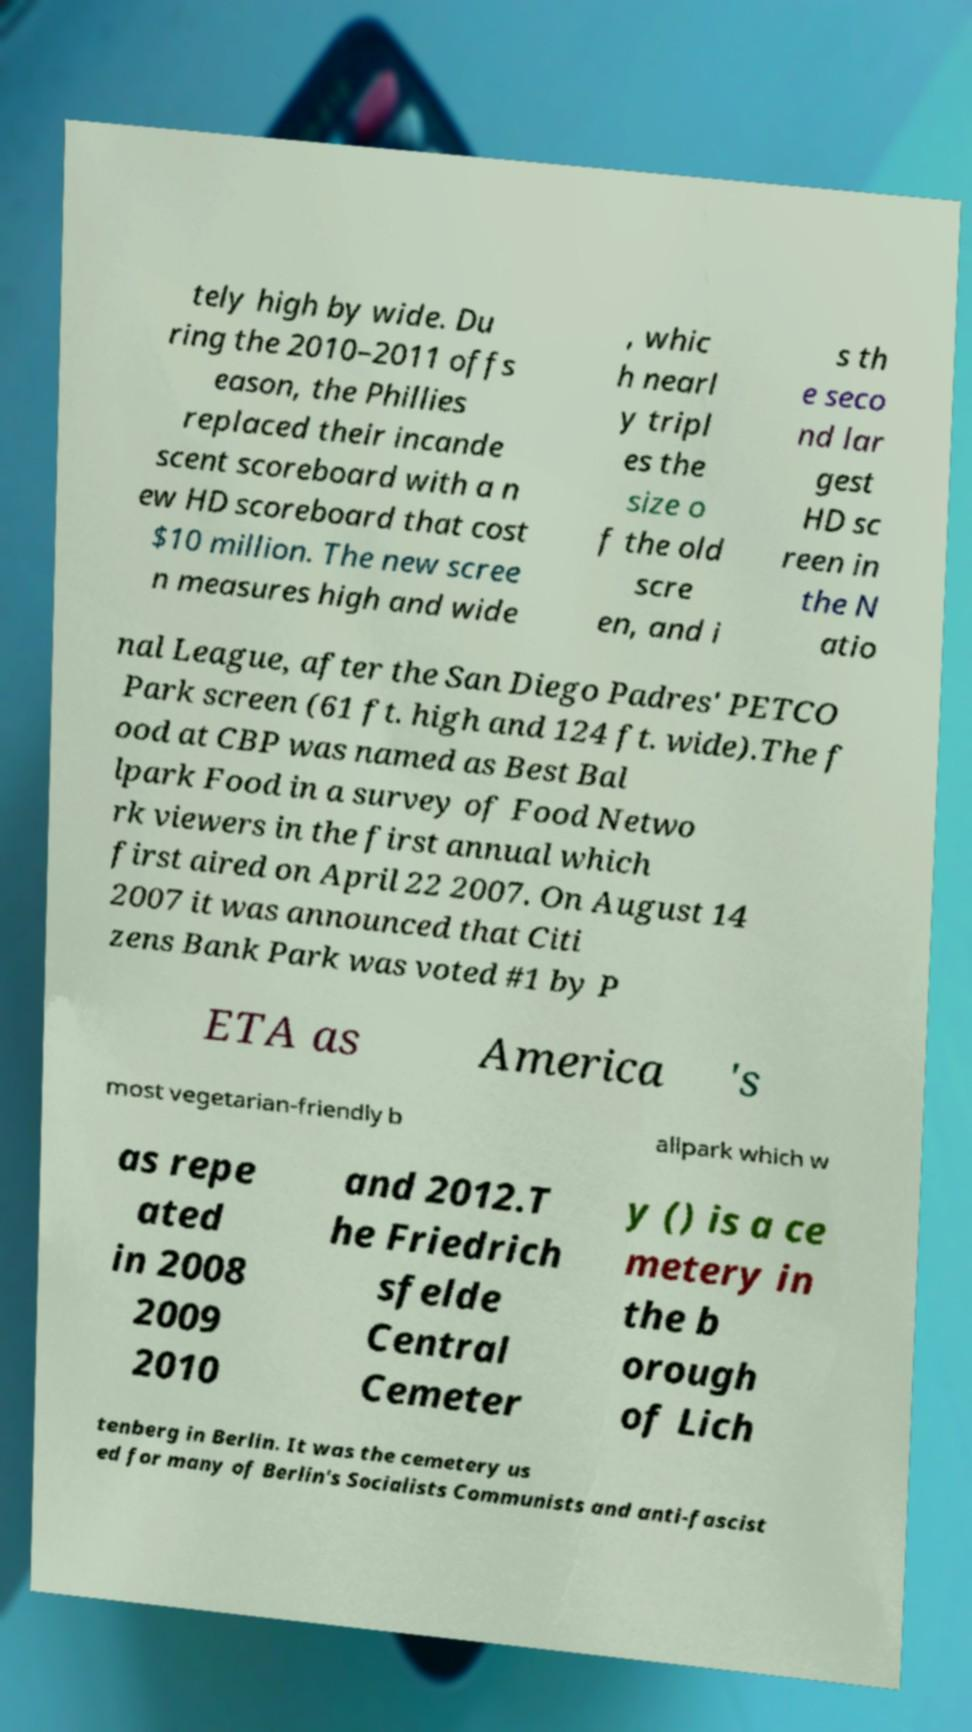I need the written content from this picture converted into text. Can you do that? tely high by wide. Du ring the 2010–2011 offs eason, the Phillies replaced their incande scent scoreboard with a n ew HD scoreboard that cost $10 million. The new scree n measures high and wide , whic h nearl y tripl es the size o f the old scre en, and i s th e seco nd lar gest HD sc reen in the N atio nal League, after the San Diego Padres' PETCO Park screen (61 ft. high and 124 ft. wide).The f ood at CBP was named as Best Bal lpark Food in a survey of Food Netwo rk viewers in the first annual which first aired on April 22 2007. On August 14 2007 it was announced that Citi zens Bank Park was voted #1 by P ETA as America 's most vegetarian-friendly b allpark which w as repe ated in 2008 2009 2010 and 2012.T he Friedrich sfelde Central Cemeter y () is a ce metery in the b orough of Lich tenberg in Berlin. It was the cemetery us ed for many of Berlin's Socialists Communists and anti-fascist 